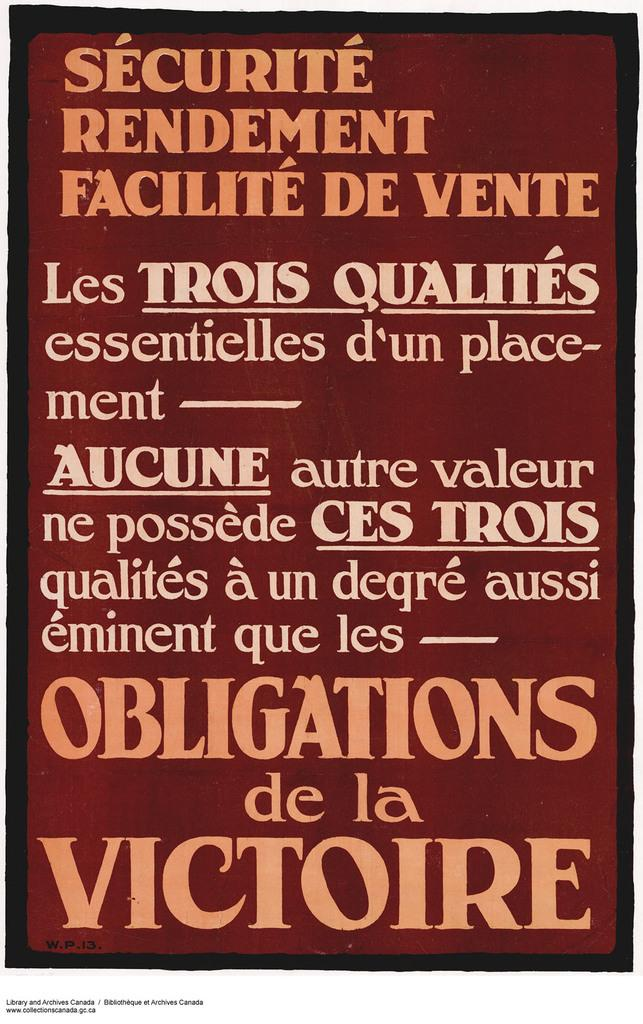<image>
Create a compact narrative representing the image presented. the word securite is on a long poster 